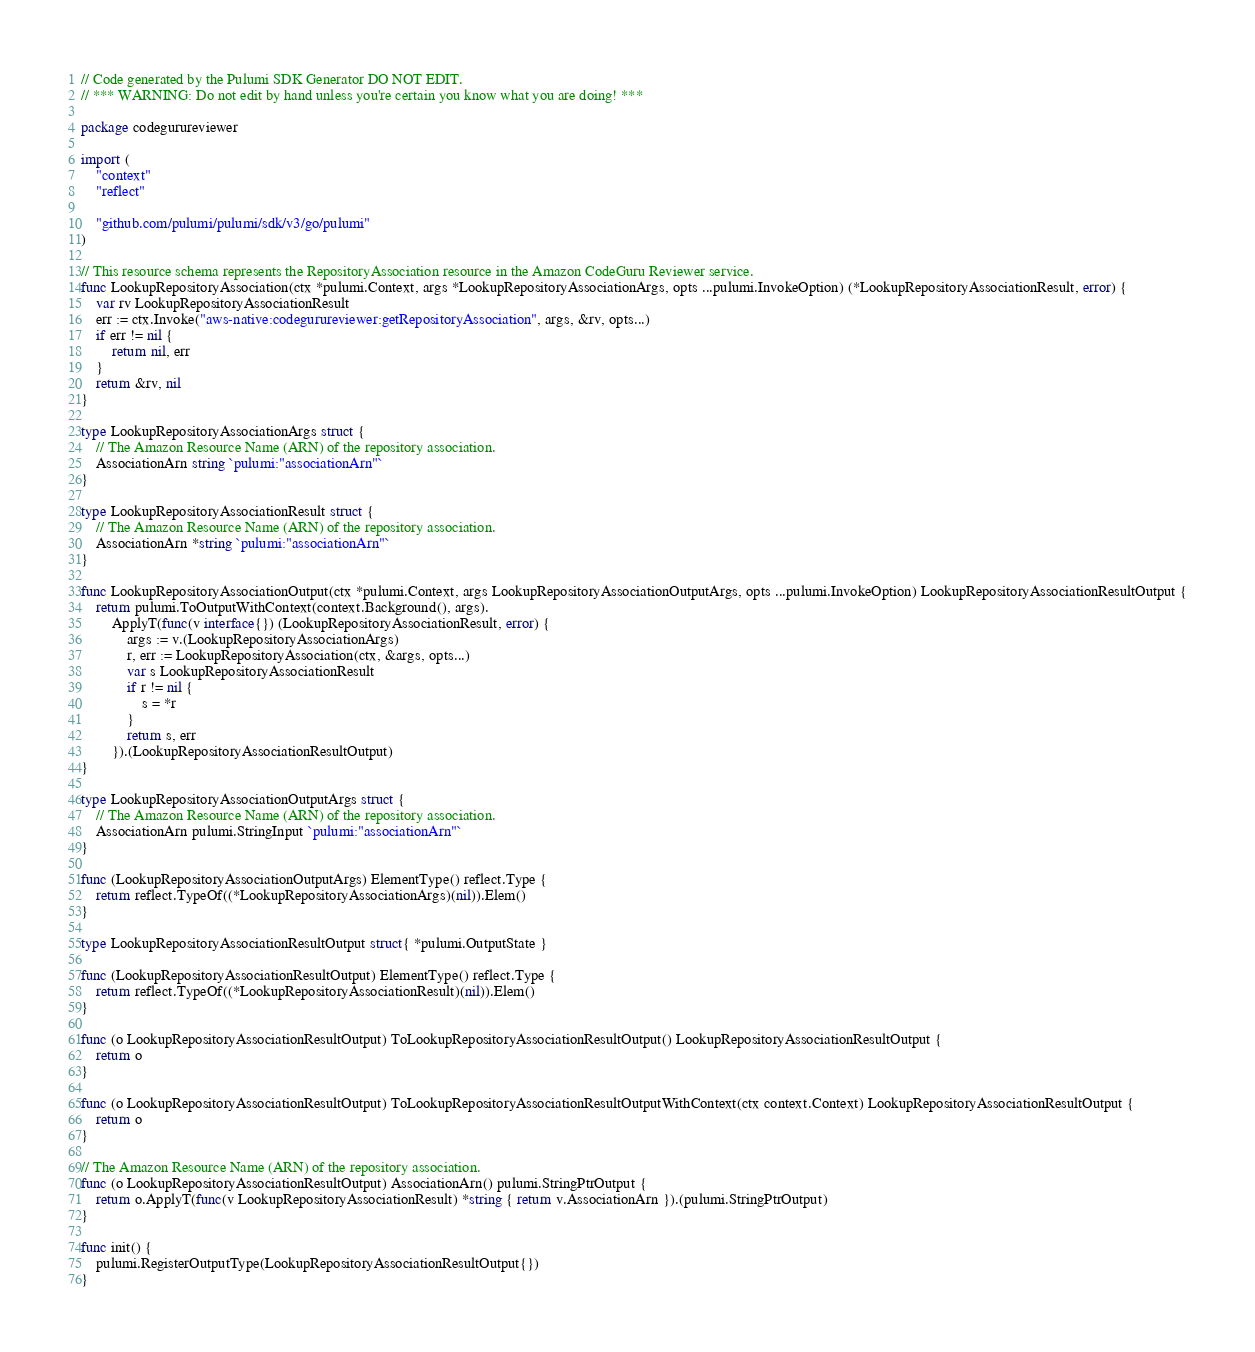Convert code to text. <code><loc_0><loc_0><loc_500><loc_500><_Go_>// Code generated by the Pulumi SDK Generator DO NOT EDIT.
// *** WARNING: Do not edit by hand unless you're certain you know what you are doing! ***

package codegurureviewer

import (
	"context"
	"reflect"

	"github.com/pulumi/pulumi/sdk/v3/go/pulumi"
)

// This resource schema represents the RepositoryAssociation resource in the Amazon CodeGuru Reviewer service.
func LookupRepositoryAssociation(ctx *pulumi.Context, args *LookupRepositoryAssociationArgs, opts ...pulumi.InvokeOption) (*LookupRepositoryAssociationResult, error) {
	var rv LookupRepositoryAssociationResult
	err := ctx.Invoke("aws-native:codegurureviewer:getRepositoryAssociation", args, &rv, opts...)
	if err != nil {
		return nil, err
	}
	return &rv, nil
}

type LookupRepositoryAssociationArgs struct {
	// The Amazon Resource Name (ARN) of the repository association.
	AssociationArn string `pulumi:"associationArn"`
}

type LookupRepositoryAssociationResult struct {
	// The Amazon Resource Name (ARN) of the repository association.
	AssociationArn *string `pulumi:"associationArn"`
}

func LookupRepositoryAssociationOutput(ctx *pulumi.Context, args LookupRepositoryAssociationOutputArgs, opts ...pulumi.InvokeOption) LookupRepositoryAssociationResultOutput {
	return pulumi.ToOutputWithContext(context.Background(), args).
		ApplyT(func(v interface{}) (LookupRepositoryAssociationResult, error) {
			args := v.(LookupRepositoryAssociationArgs)
			r, err := LookupRepositoryAssociation(ctx, &args, opts...)
			var s LookupRepositoryAssociationResult
			if r != nil {
				s = *r
			}
			return s, err
		}).(LookupRepositoryAssociationResultOutput)
}

type LookupRepositoryAssociationOutputArgs struct {
	// The Amazon Resource Name (ARN) of the repository association.
	AssociationArn pulumi.StringInput `pulumi:"associationArn"`
}

func (LookupRepositoryAssociationOutputArgs) ElementType() reflect.Type {
	return reflect.TypeOf((*LookupRepositoryAssociationArgs)(nil)).Elem()
}

type LookupRepositoryAssociationResultOutput struct{ *pulumi.OutputState }

func (LookupRepositoryAssociationResultOutput) ElementType() reflect.Type {
	return reflect.TypeOf((*LookupRepositoryAssociationResult)(nil)).Elem()
}

func (o LookupRepositoryAssociationResultOutput) ToLookupRepositoryAssociationResultOutput() LookupRepositoryAssociationResultOutput {
	return o
}

func (o LookupRepositoryAssociationResultOutput) ToLookupRepositoryAssociationResultOutputWithContext(ctx context.Context) LookupRepositoryAssociationResultOutput {
	return o
}

// The Amazon Resource Name (ARN) of the repository association.
func (o LookupRepositoryAssociationResultOutput) AssociationArn() pulumi.StringPtrOutput {
	return o.ApplyT(func(v LookupRepositoryAssociationResult) *string { return v.AssociationArn }).(pulumi.StringPtrOutput)
}

func init() {
	pulumi.RegisterOutputType(LookupRepositoryAssociationResultOutput{})
}
</code> 